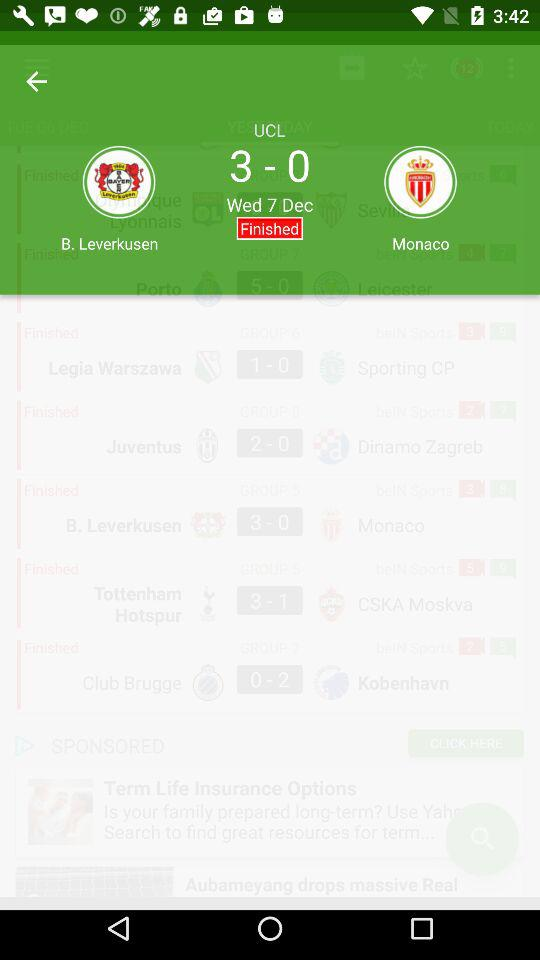On what date was the match finished? The date was Wednesday, December 7. 